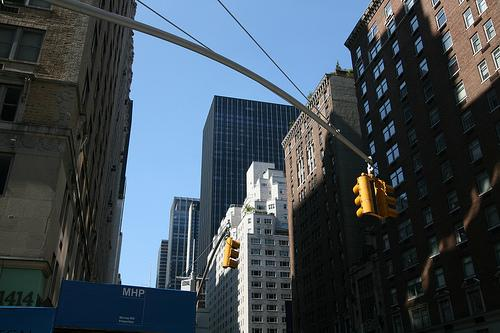Describe the urban environment visible in the photograph. The image showcases a city street with multi-story buildings, a traffic light hanging from a pole, and a blue box featuring a white "mhp" inscription. Mention the dominant colors and objects that you can observe in the image. In the image, the sky is blue, buildings are white and dark brown, the traffic light is yellow, and there is a blue box with white text "mhp". Provide a brief description of the primary objects in the photo. The image shows a clear blue sky, tall buildings with numerous windows, a traffic light hanging on a metal pole, and a blue box with "mhp" written on it. Summarize the main features present in the image. The image portrays an urban setting with buildings, a traffic light, a blue box with the text "mhp," and a clear blue sky. State the main subjects of the image in a simple and short sentence. The image displays buildings, a traffic light, and a blue box under a clear blue sky. Write a concise summary of the visible aspects of the photograph. The photo shows a cityscape with tall buildings, a yellow traffic light, a blue box marked "mhp", and a bright blue sky. Explain the scene you see in the picture with a focus on the important elements. The scene displays a city street with tall buildings, a traffic light on a metal pole, and a blue box with "mhp" written, all under a clear blue sky. Briefly explain the contents of the image, focusing on the key details. The image depicts a city scene with tall buildings, a yellow traffic light mounted on a pole, and a prominently placed blue box with "mhp" written on it. Briefly describe what you see happening in the image. The image captures a city street scene featuring buildings with windows, a hanging traffic light, and a blue box labeled "mhp" against a blue sky. Identify the main elements in the image and the colors used. The image contains tall buildings, a yellow traffic light, a blue box with "mhp" written on it, and a blue sky for the background. 